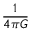<formula> <loc_0><loc_0><loc_500><loc_500>\frac { 1 } { 4 \pi G }</formula> 